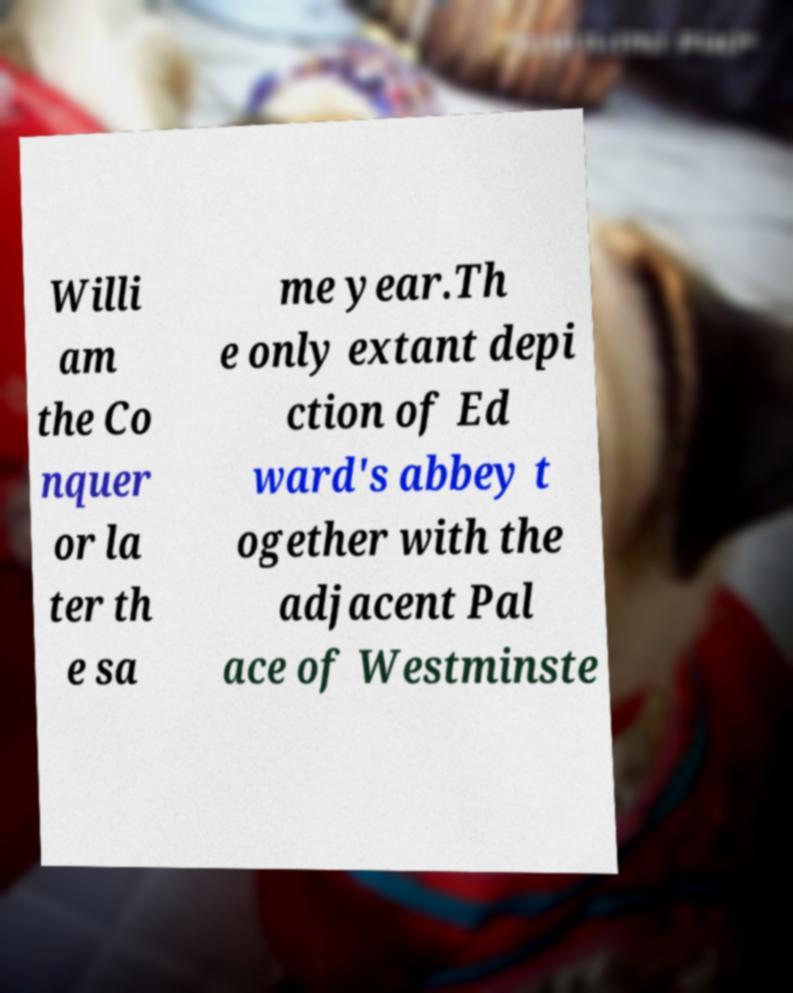I need the written content from this picture converted into text. Can you do that? Willi am the Co nquer or la ter th e sa me year.Th e only extant depi ction of Ed ward's abbey t ogether with the adjacent Pal ace of Westminste 